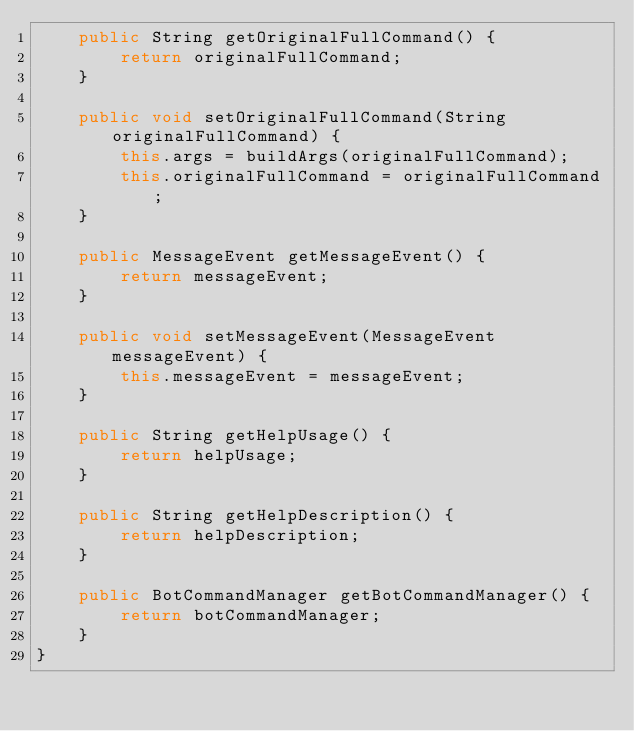<code> <loc_0><loc_0><loc_500><loc_500><_Java_>    public String getOriginalFullCommand() {
        return originalFullCommand;
    }

    public void setOriginalFullCommand(String originalFullCommand) {
        this.args = buildArgs(originalFullCommand);
        this.originalFullCommand = originalFullCommand;
    }

    public MessageEvent getMessageEvent() {
        return messageEvent;
    }

    public void setMessageEvent(MessageEvent messageEvent) {
        this.messageEvent = messageEvent;
    }

    public String getHelpUsage() {
        return helpUsage;
    }

    public String getHelpDescription() {
        return helpDescription;
    }

    public BotCommandManager getBotCommandManager() {
        return botCommandManager;
    }
}
</code> 